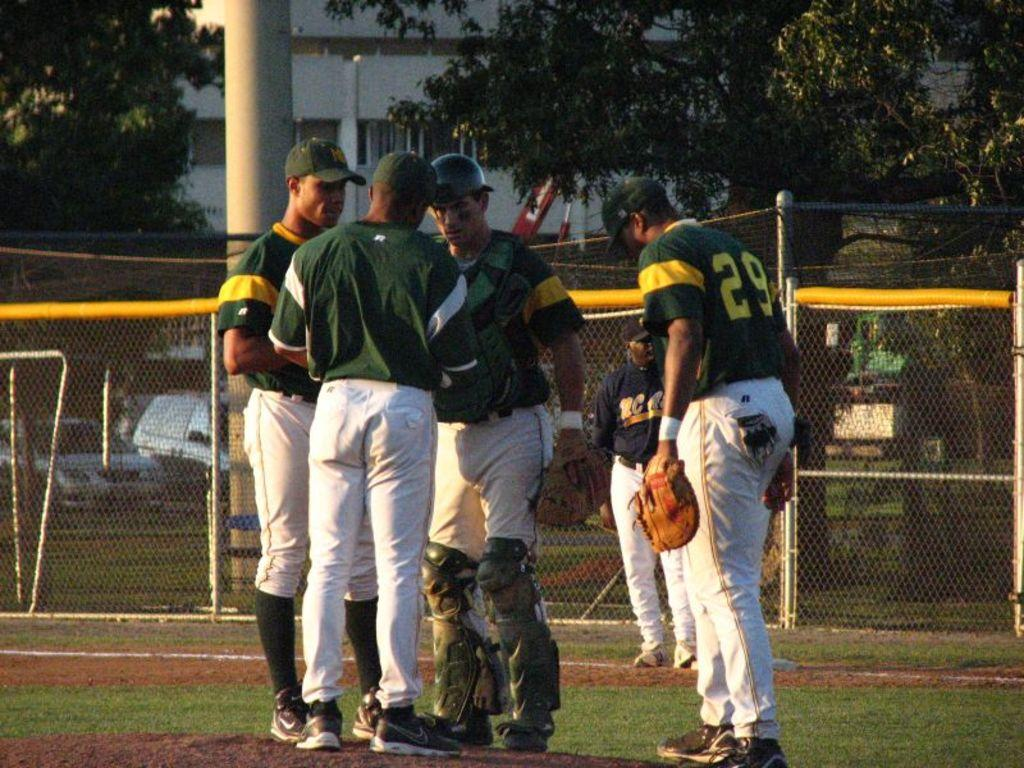<image>
Provide a brief description of the given image. Number 29 is on the back of the jersey of the player in the huddle. 